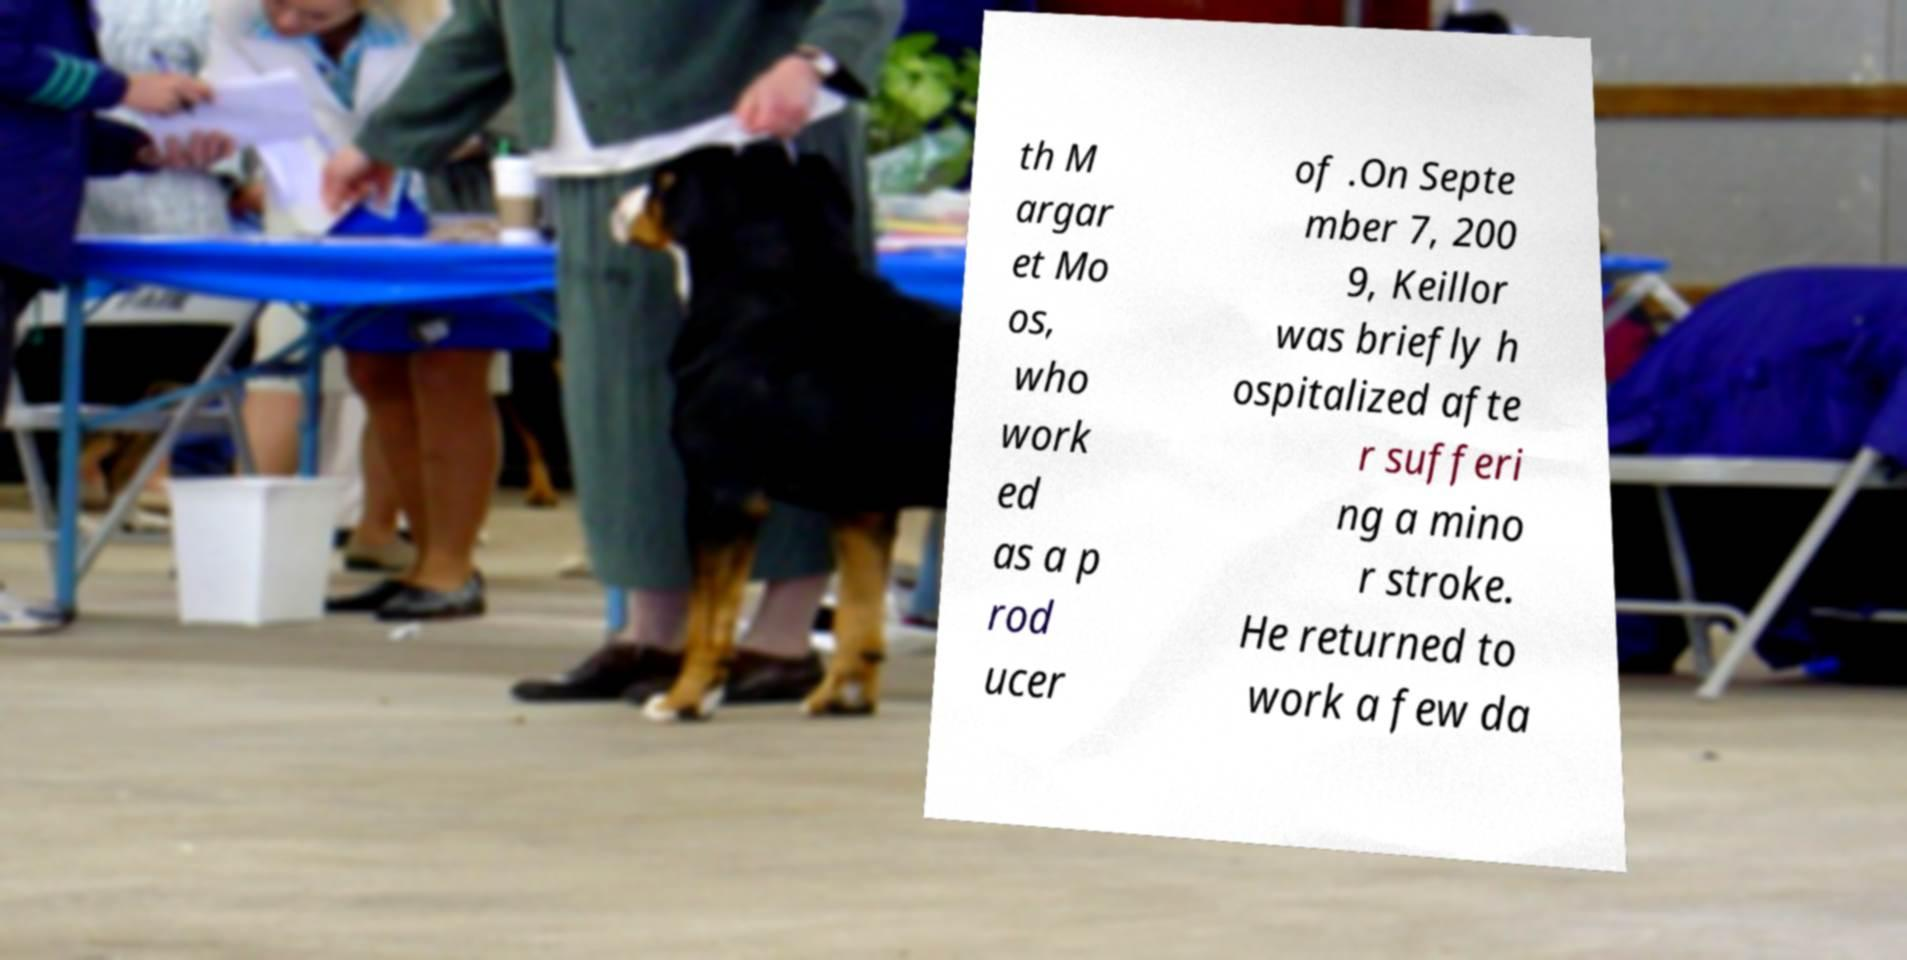Please read and relay the text visible in this image. What does it say? th M argar et Mo os, who work ed as a p rod ucer of .On Septe mber 7, 200 9, Keillor was briefly h ospitalized afte r sufferi ng a mino r stroke. He returned to work a few da 